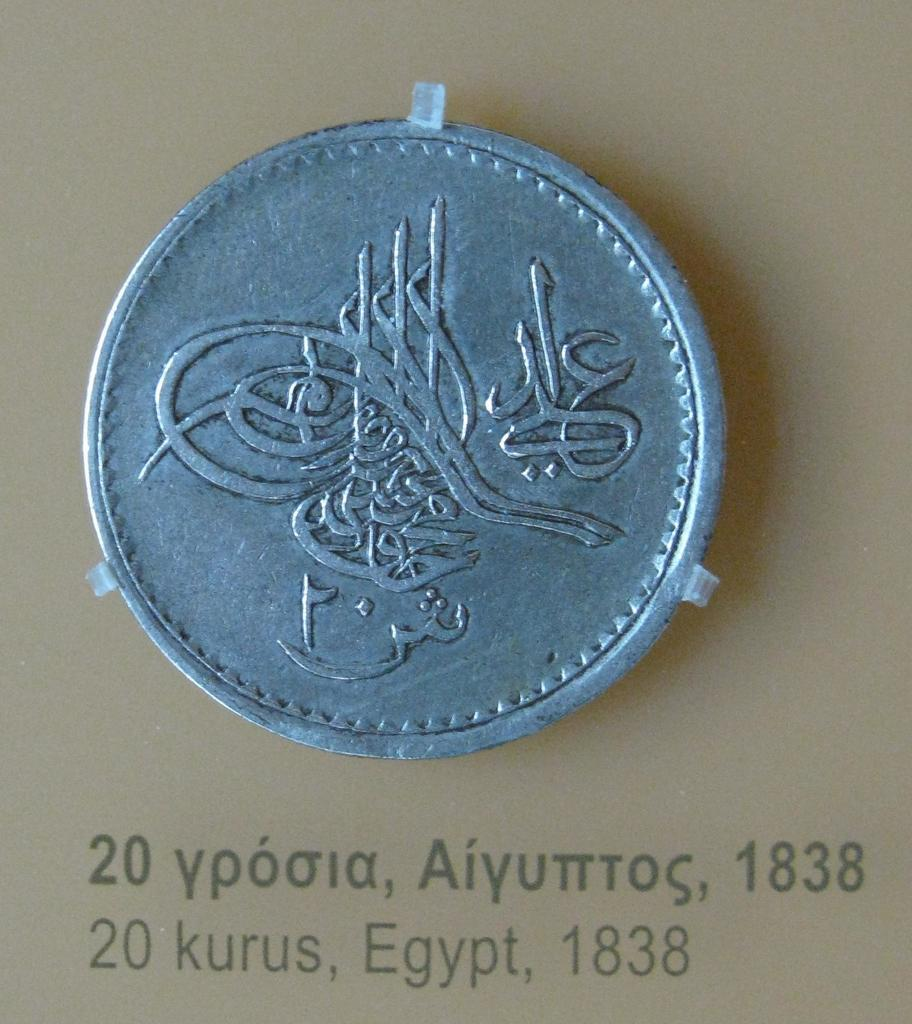<image>
Share a concise interpretation of the image provided. An Egyptian twenty Kuru coin minted in 1838. 